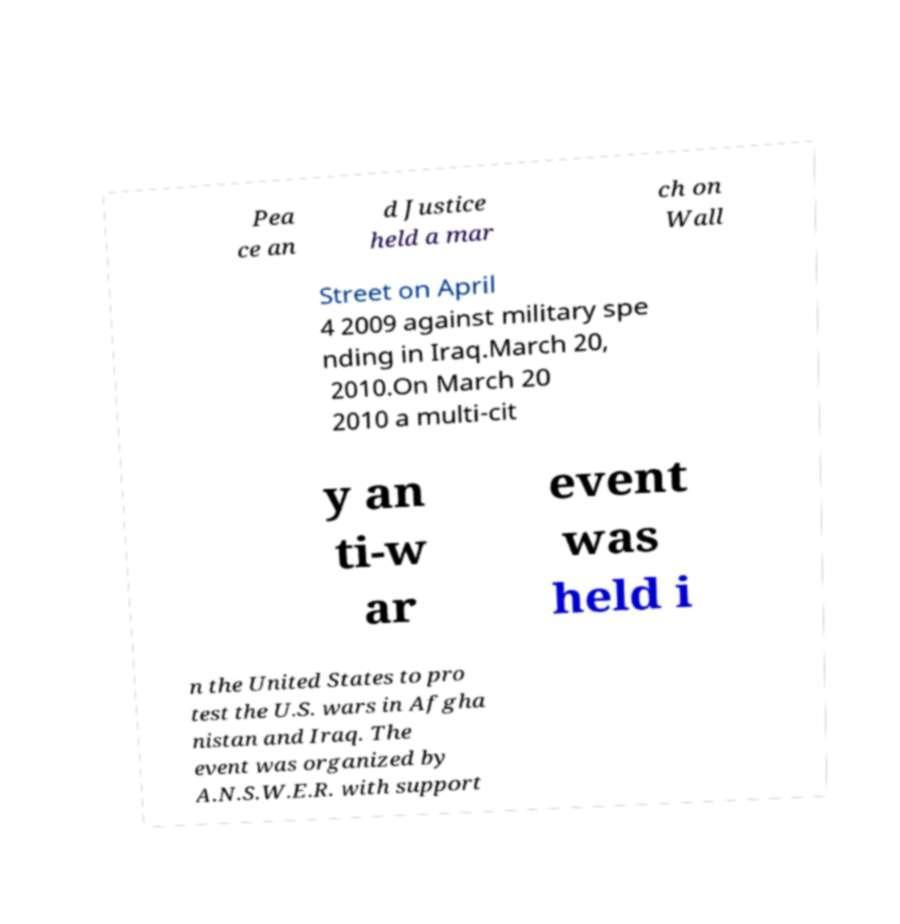Can you read and provide the text displayed in the image?This photo seems to have some interesting text. Can you extract and type it out for me? Pea ce an d Justice held a mar ch on Wall Street on April 4 2009 against military spe nding in Iraq.March 20, 2010.On March 20 2010 a multi-cit y an ti-w ar event was held i n the United States to pro test the U.S. wars in Afgha nistan and Iraq. The event was organized by A.N.S.W.E.R. with support 